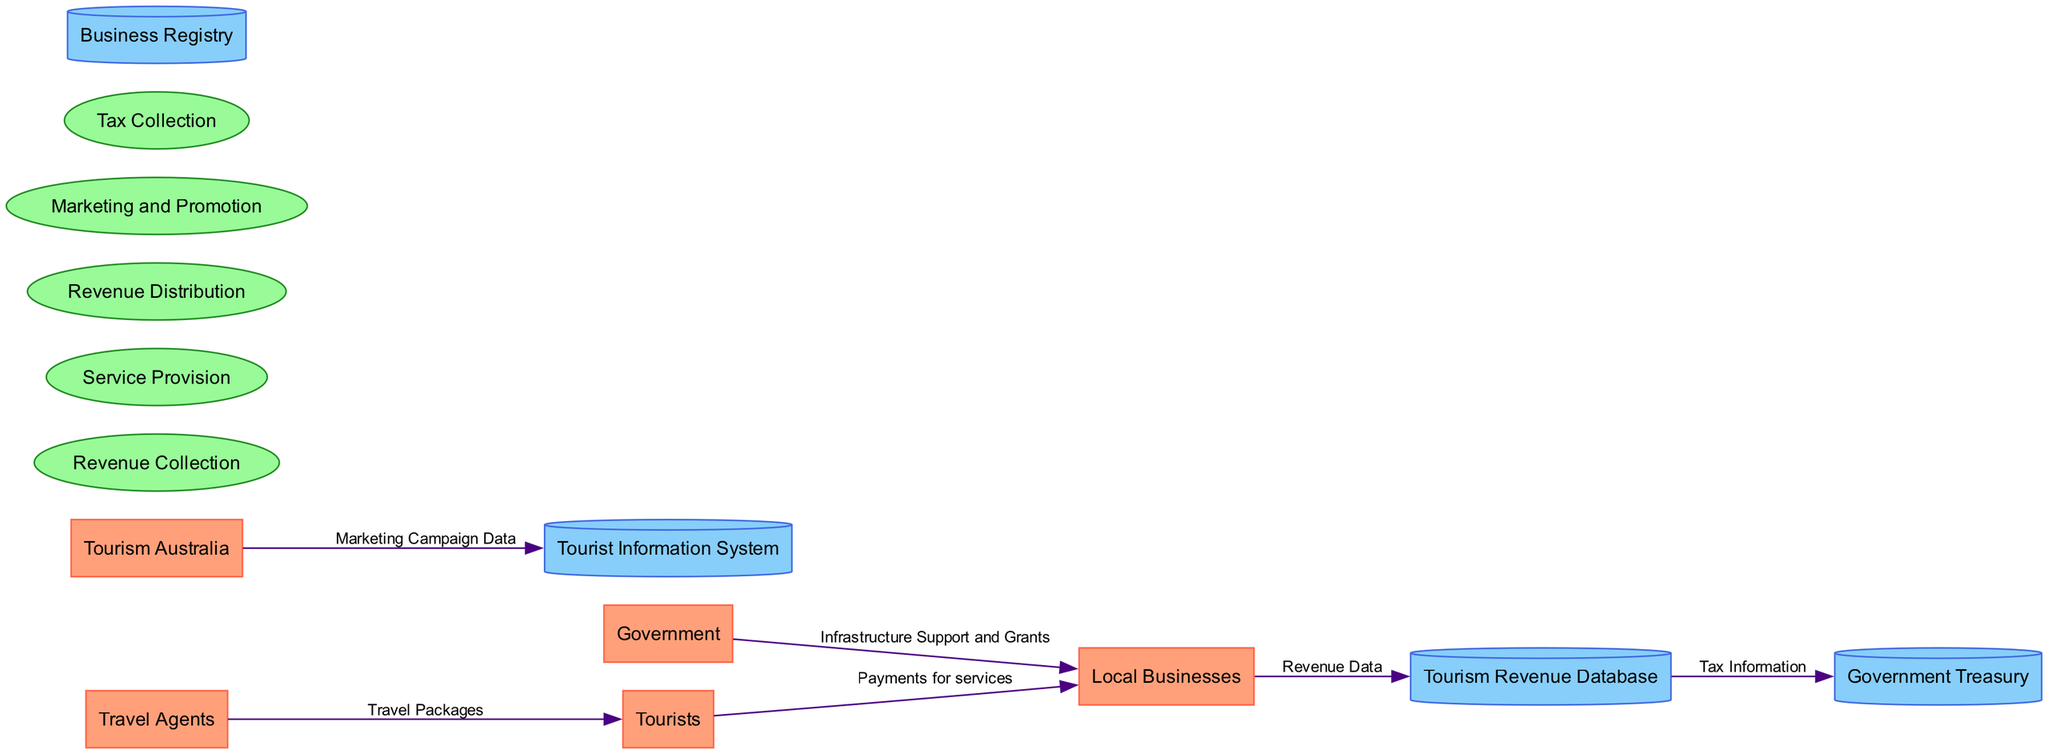What are the entities in the diagram? The diagram presents several entities, including Tourists, Tourism Australia, Local Businesses, Travel Agents, and Government. These entities represent the participants in the Australian tourism industry.
Answer: Tourists, Tourism Australia, Local Businesses, Travel Agents, Government How many processes are depicted in the diagram? The diagram includes five processes: Revenue Collection, Service Provision, Revenue Distribution, Marketing and Promotion, and Tax Collection. Counting these reveals that there are a total of five distinct processes involved in revenue generation and distribution.
Answer: 5 What data flow comes from Local Businesses to the Tourism Revenue Database? The data flow from Local Businesses to the Tourism Revenue Database is labeled "Revenue Data." This indicates that local businesses report their earnings through this specific data flow to this database.
Answer: Revenue Data Which entity supports Local Businesses with grants? The Government entity provides support to Local Businesses through "Infrastructure Support and Grants." This means that the government plays a role in assisting businesses involved in the tourism industry.
Answer: Government What type of information does the Tourist Information System hold? The Tourist Information System maintains data regarding tourist preferences, travel history, and feedback. This type of information is crucial for understanding tourist behavior and improving services.
Answer: Tourist preferences, travel history, and feedback Identify the final destination of Tax Information in the data flow. The Tax Information from the Tourism Revenue Database flows to the Government Treasury. This indicates that tax-related data collected from tourism businesses is managed by the treasury department.
Answer: Government Treasury How does Tourism Australia influence the Tourist Information System? Tourism Australia sends "Marketing Campaign Data" to the Tourist Information System. This signifies that the government agency's marketing efforts are recorded in this system to analyze the impact of campaigns on tourist behavior.
Answer: Marketing Campaign Data What is the main function of the Revenue Distribution process? The Revenue Distribution process is focused on allocating collected revenue among stakeholders, which includes local businesses, government, and agencies. This function is vital in ensuring that revenues are fairly divided among participants in the tourism industry.
Answer: Distribution of collected revenue 